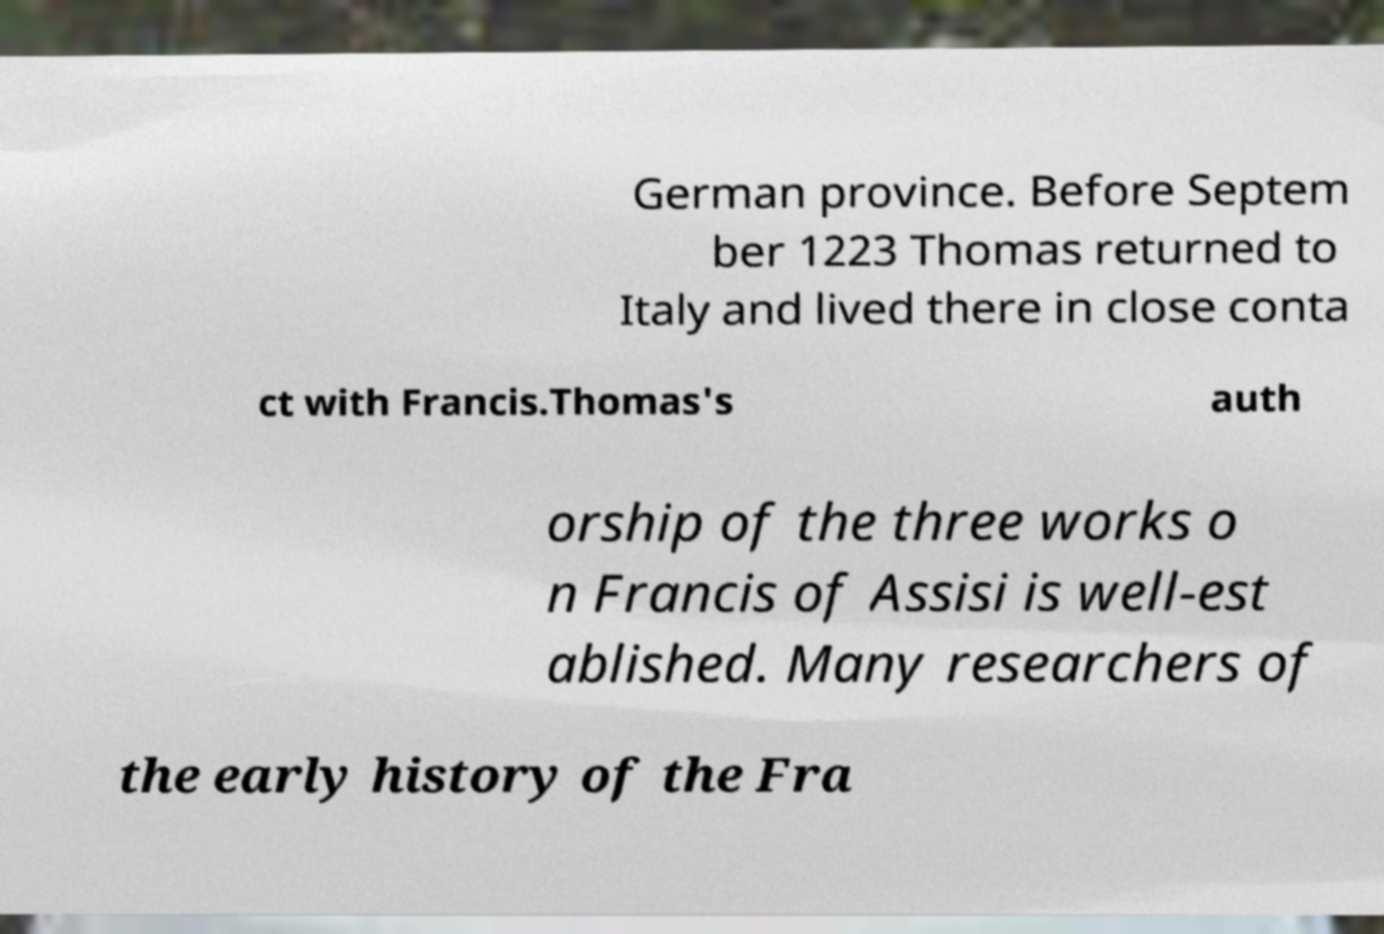Could you extract and type out the text from this image? German province. Before Septem ber 1223 Thomas returned to Italy and lived there in close conta ct with Francis.Thomas's auth orship of the three works o n Francis of Assisi is well-est ablished. Many researchers of the early history of the Fra 